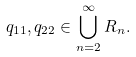Convert formula to latex. <formula><loc_0><loc_0><loc_500><loc_500>q _ { 1 1 } , q _ { 2 2 } \in \bigcup _ { n = 2 } ^ { \infty } R _ { n } .</formula> 